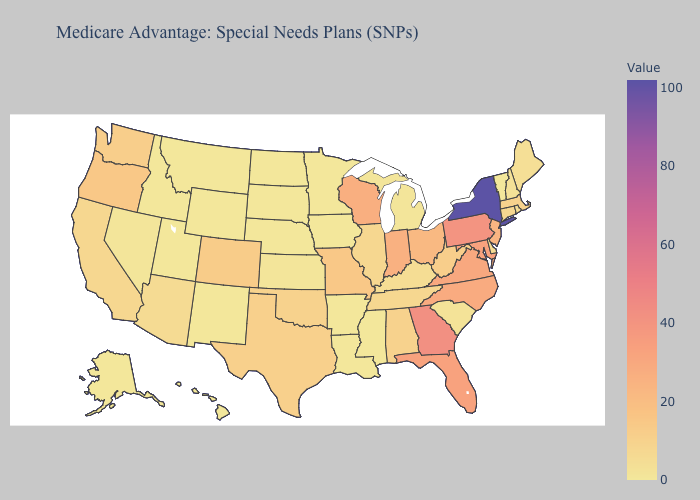Does Wisconsin have the highest value in the MidWest?
Quick response, please. Yes. Which states hav the highest value in the Northeast?
Quick response, please. New York. 